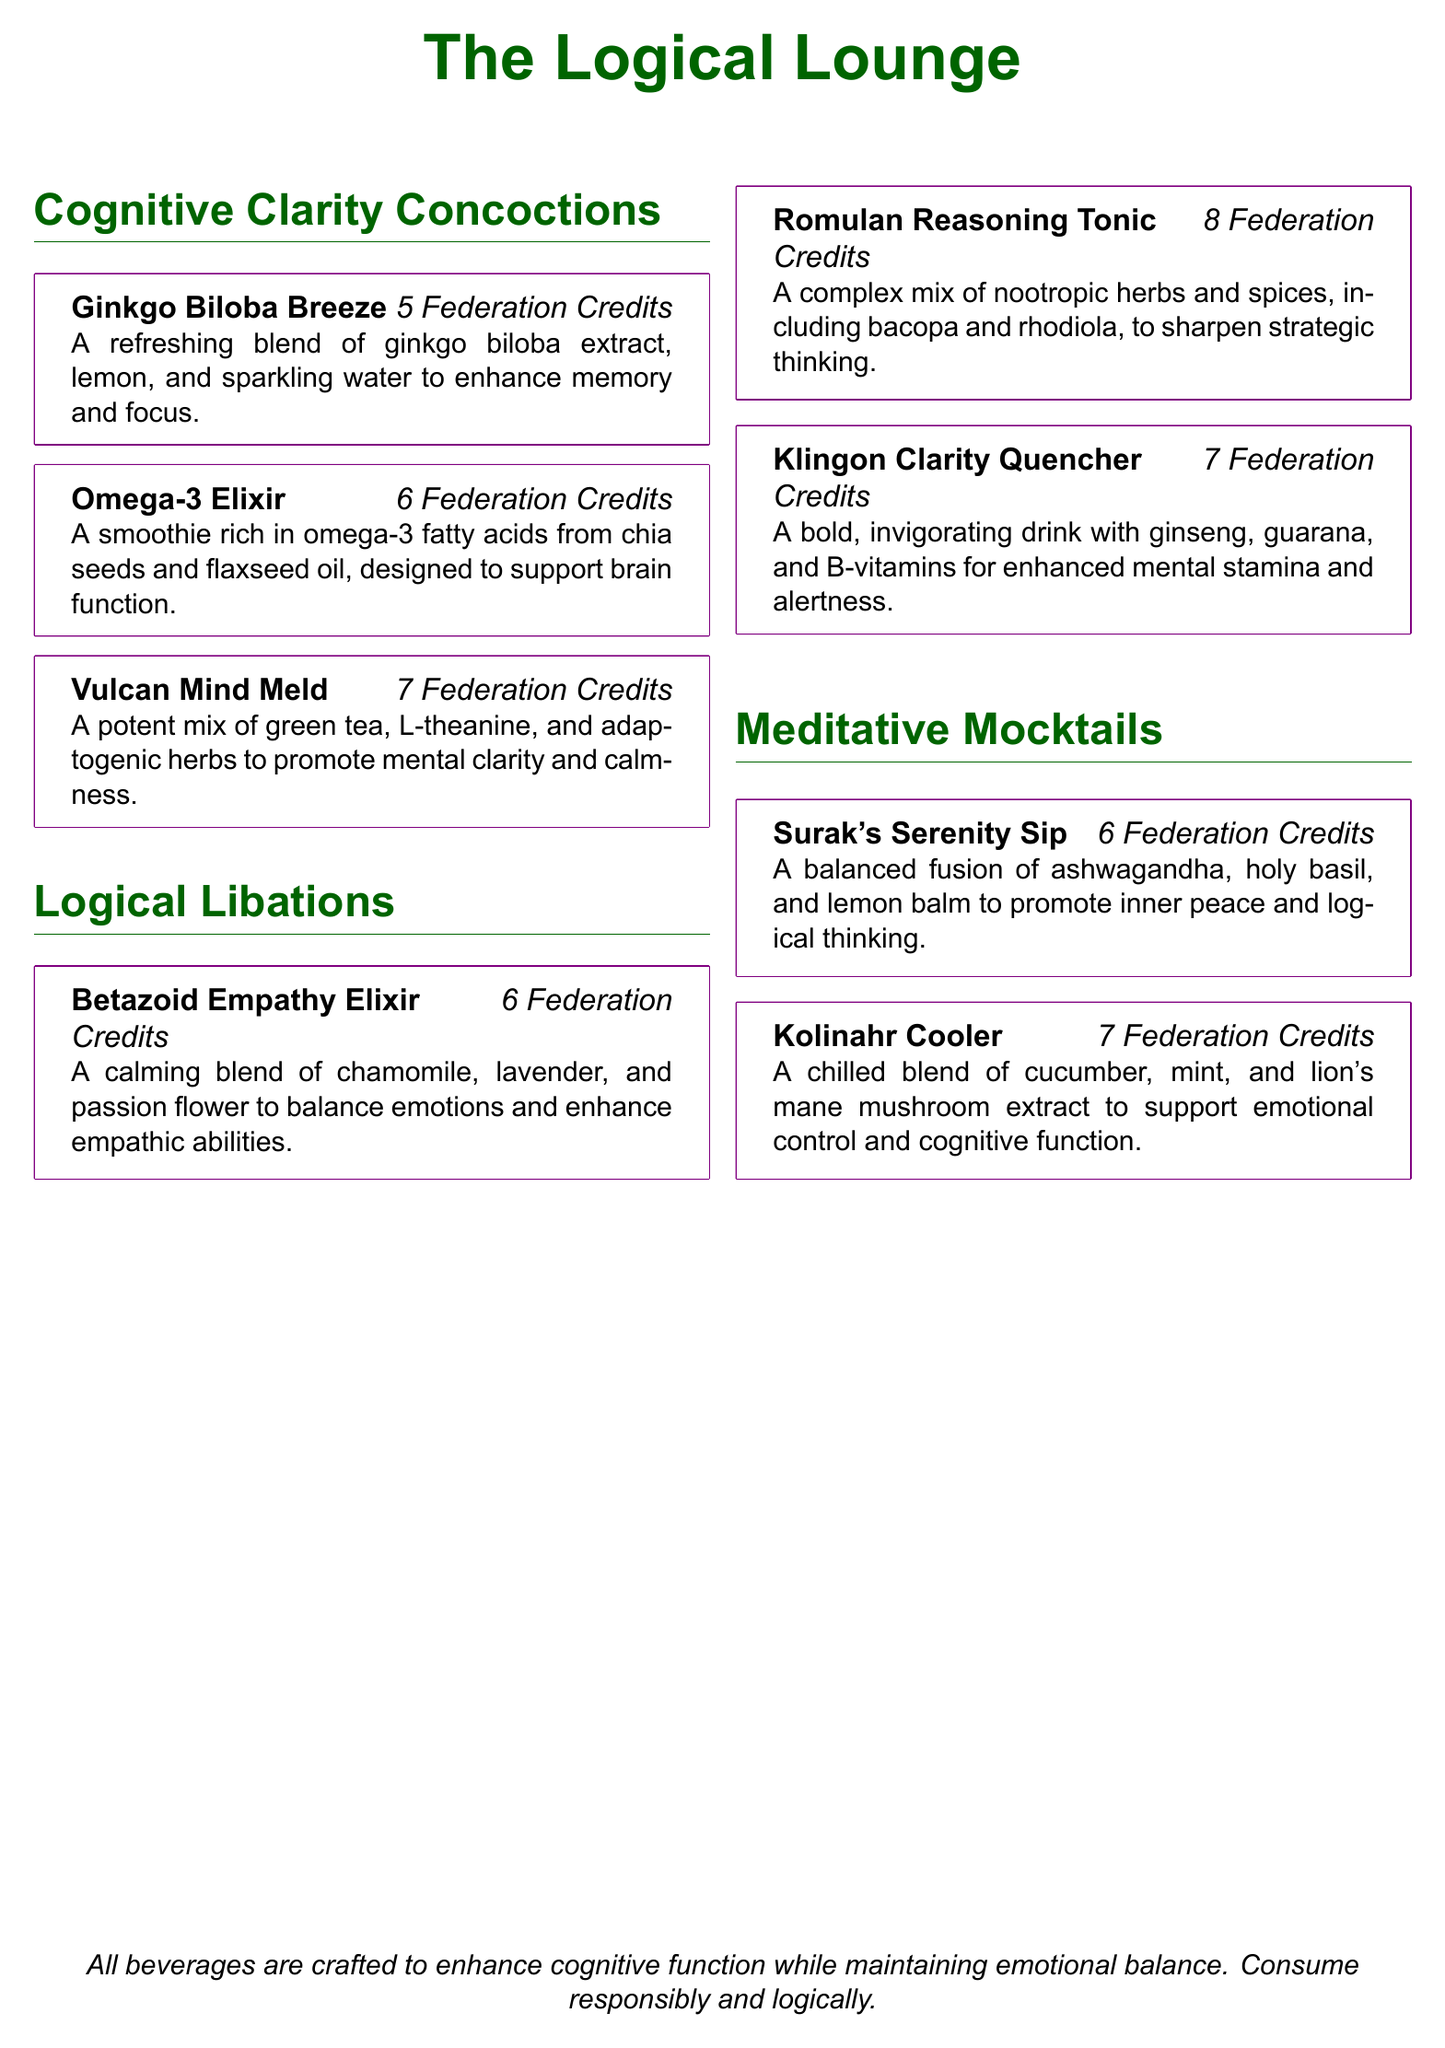What is the price of Ginkgo Biloba Breeze? The price of Ginkgo Biloba Breeze is listed in the document under its description.
Answer: 5 Federation Credits What ingredients are in the Omega-3 Elixir? The ingredients for the Omega-3 Elixir are specified in its description.
Answer: Chia seeds and flaxseed oil How many Cognitive Clarity Concoctions are offered? The total number of Cognitive Clarity Concoctions can be counted from the menu section.
Answer: 3 What is the main purpose of the Betazoid Empathy Elixir? The primary purpose of the Betazoid Empathy Elixir is mentioned in its description.
Answer: Balance emotions and enhance empathic abilities Which drink is specifically associated with promoting mental clarity and calmness? The drink associated with mental clarity and calmness can be found in the menu items.
Answer: Vulcan Mind Meld What is the cost of the Klingon Clarity Quencher? The cost of the Klingon Clarity Quencher is stated alongside its description.
Answer: 7 Federation Credits How many Meditative Mocktails are listed? The number of Meditative Mocktails can be determined from the document's section on mocktails.
Answer: 2 Which item contains lion's mane mushroom extract? The item that includes lion's mane mushroom extract is specified in the document.
Answer: Kolinahr Cooler What is the color associated with the document's title? The color of the document's title is described in the formatting section.
Answer: Vulcan green 